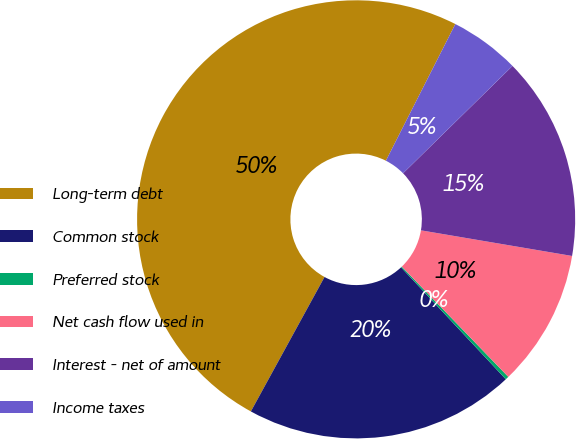Convert chart to OTSL. <chart><loc_0><loc_0><loc_500><loc_500><pie_chart><fcel>Long-term debt<fcel>Common stock<fcel>Preferred stock<fcel>Net cash flow used in<fcel>Interest - net of amount<fcel>Income taxes<nl><fcel>49.5%<fcel>19.95%<fcel>0.25%<fcel>10.1%<fcel>15.02%<fcel>5.17%<nl></chart> 